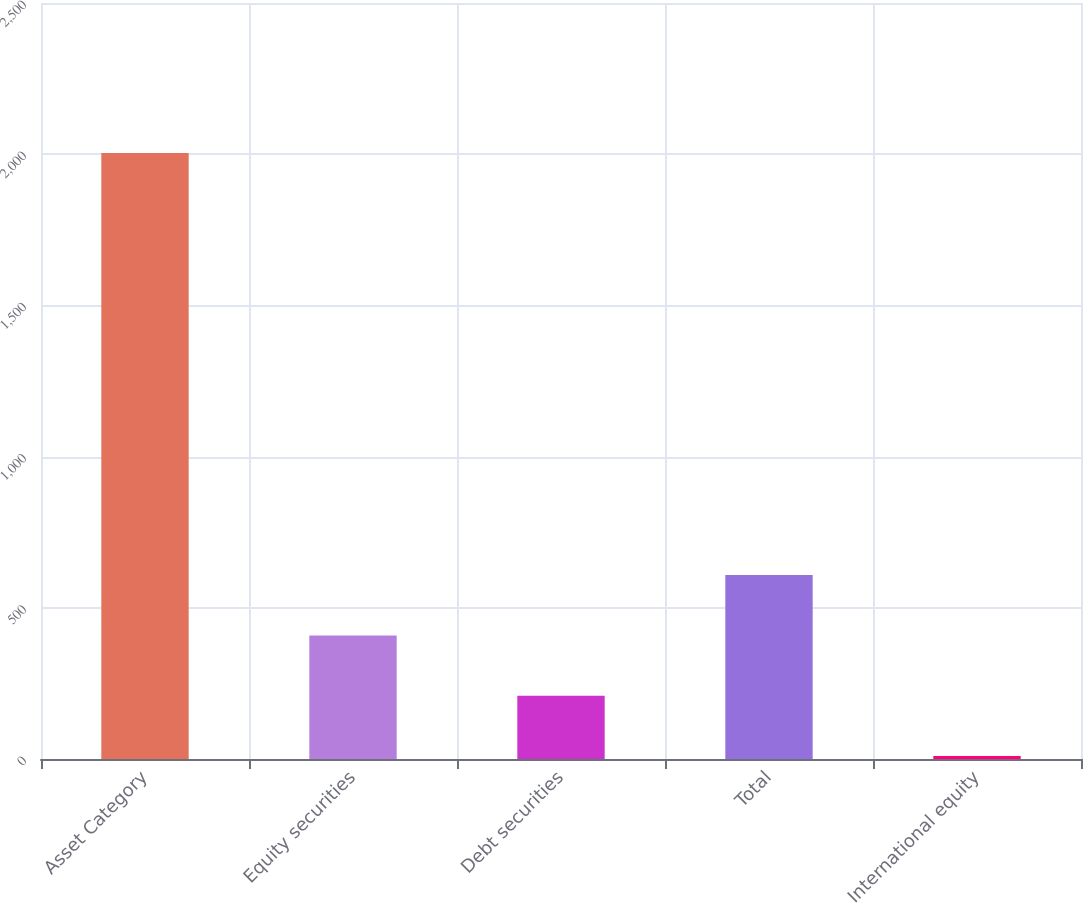Convert chart. <chart><loc_0><loc_0><loc_500><loc_500><bar_chart><fcel>Asset Category<fcel>Equity securities<fcel>Debt securities<fcel>Total<fcel>International equity<nl><fcel>2004<fcel>408.8<fcel>209.4<fcel>608.2<fcel>10<nl></chart> 